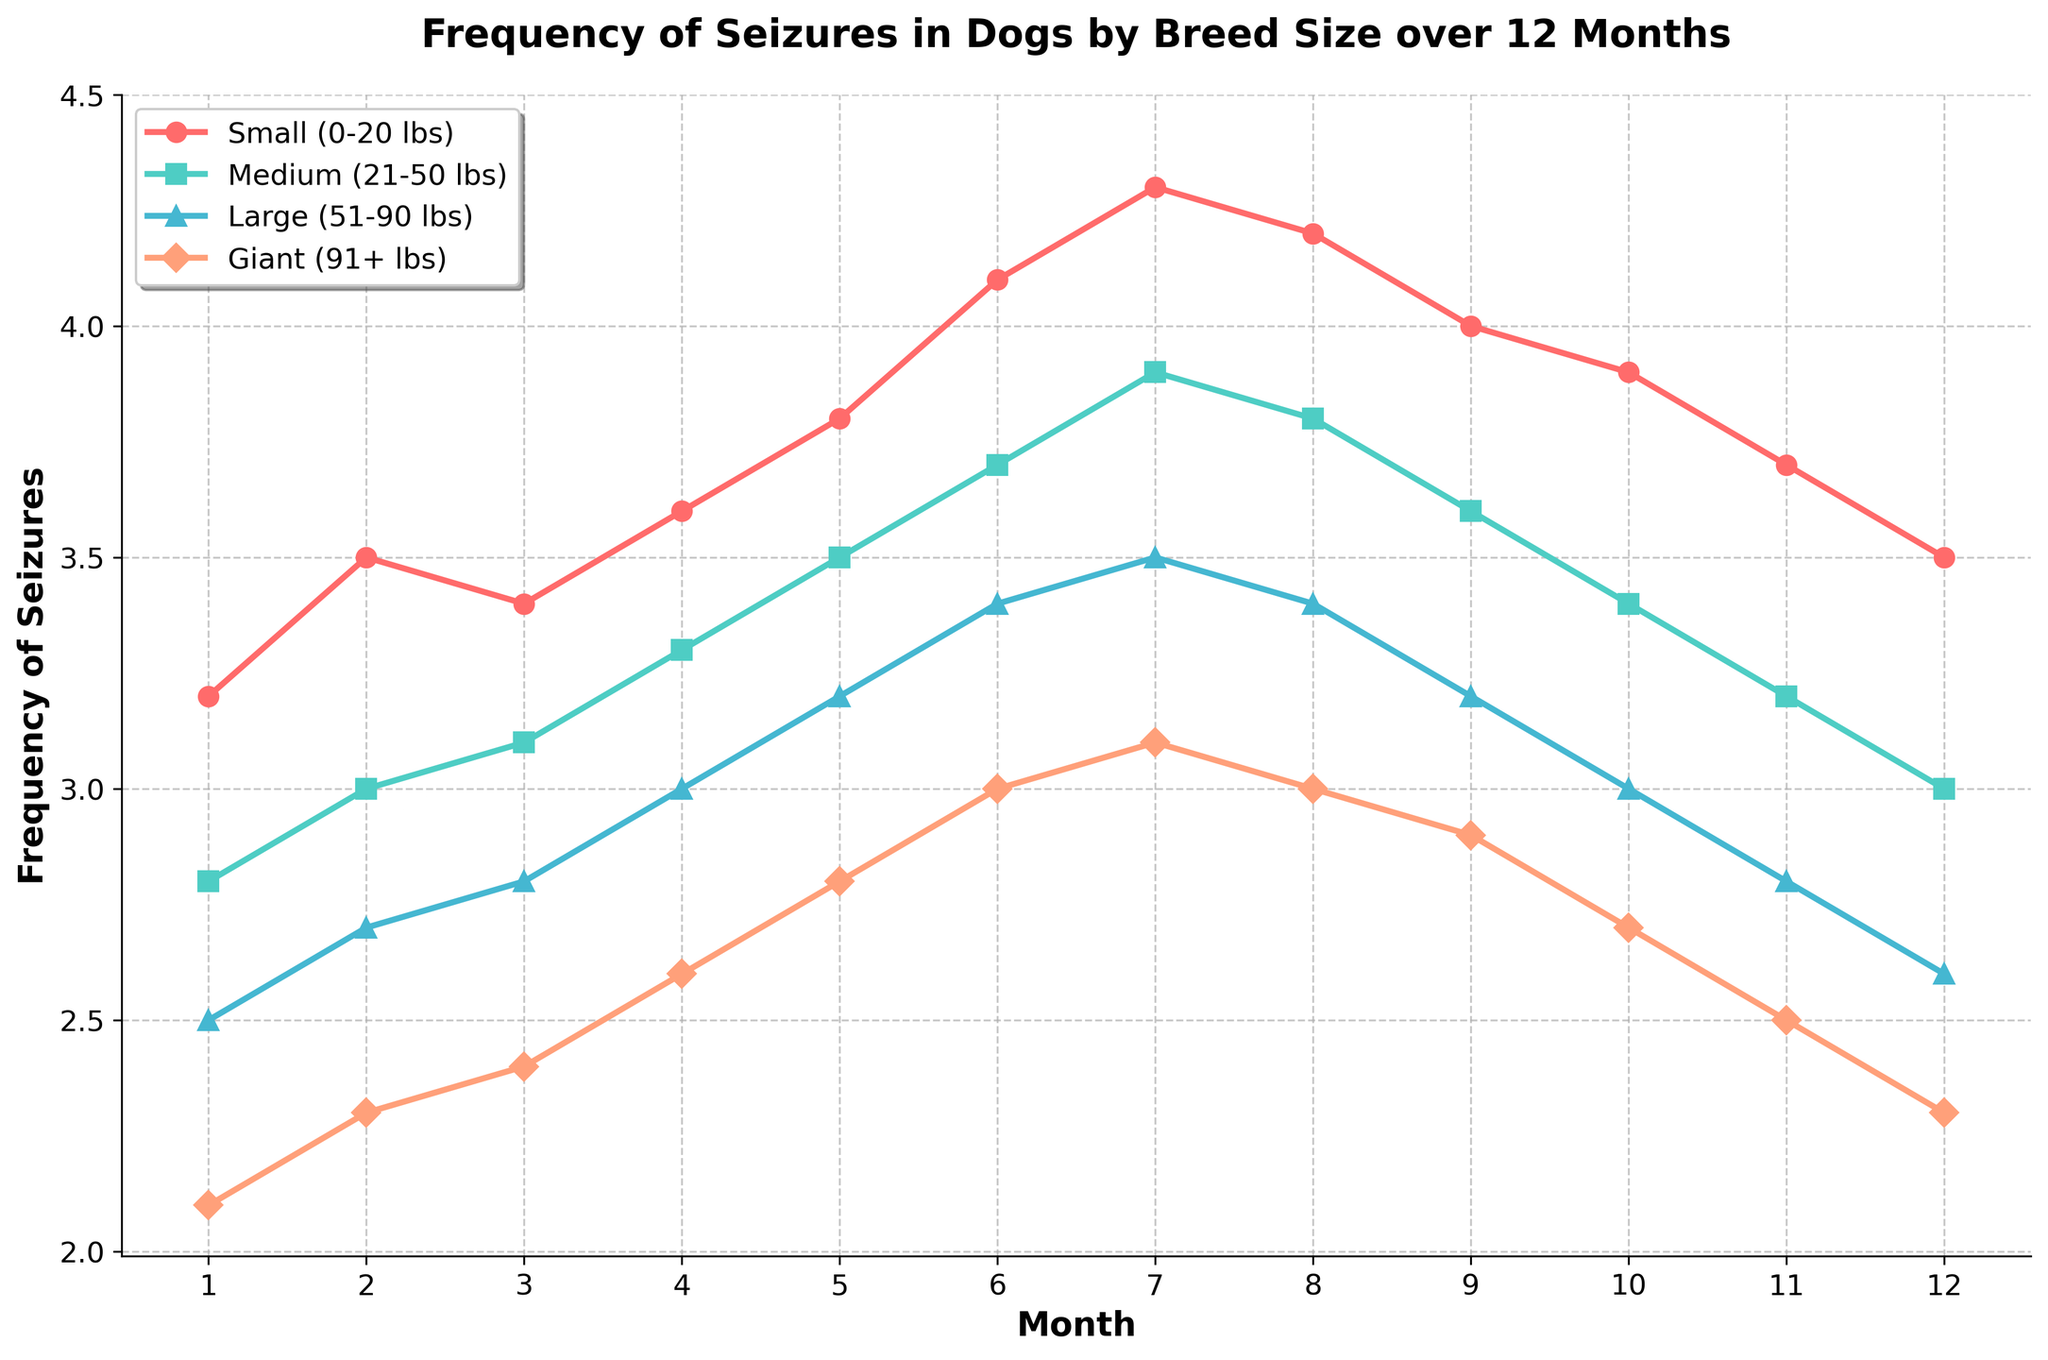What is the general trend for the frequency of seizures in small breed dogs over 12 months? The figure shows the frequency of seizures in small breed dogs from month 1 to month 12. The trend starts at 3.2 and gradually increases to 4.3 in month 7, then it slightly declines to 3.5 by month 12. The overall trend is an increase followed by a slight decrease.
Answer: Increasing then decreasing Which breed size had the highest frequency of seizures in month 6? By examining the lines in the figure for month 6, we observe that small breed dogs have the highest frequency at 4.1, compared to 3.7 for medium, 3.4 for large, and 3.0 for giant breeds.
Answer: Small breed Which breed size shows the most significant increase in seizure frequency from month 1 to month 12? To find this, we calculate the differences for each breed from month 1 to month 12. Small breeds increase from 3.2 to 3.5 (0.3 increase), medium breeds from 2.8 to 3.0 (0.2 increase), large breeds from 2.5 to 2.6 (0.1 increase), and giant breeds from 2.1 to 2.3 (0.2 increase). The most significant increase is seen in small breed dogs.
Answer: Small breed On average, what is the frequency of seizures for giant breed dogs over the 12-month period? The average is calculated by summing the monthly frequencies and dividing by 12. Summing the values (2.1 + 2.3 + 2.4 + 2.6 + 2.8 + 3.0 + 3.1 + 3.0 + 2.9 + 2.7 + 2.5 + 2.3) equals 33.7. The average frequency is 33.7/12.
Answer: 2.81 How does the trend in seizure frequency for medium breed dogs compare to large breed dogs from month 3 to month 9? Between months 3 and 9, we see a gradual increase in both medium and large breeds. The medium breed rises from 3.1 to 3.6, while the large breed goes from 2.8 to 3.2. Both show a similar upward trend, but medium breeds have a consistently higher frequency throughout this period.
Answer: Both increase, medium breeds higher Which breed size experienced the least fluctuation in seizure frequency over the year? Fluctuation can be observed by the range (difference between the highest and lowest values) for each breed size. Small: 4.3 - 3.2 = 1.1, Medium: 3.9 - 2.8 = 1.1, Large: 3.5 - 2.5 = 1.0, Giant: 3.1 - 2.1 = 1.0. Giant and Large breeds have the same smallest range.
Answer: Giant and Large breeds By month 10, which breed shows a decrease in seizure frequency compared to month 8? Looking at month 8 and month 10, small breeds go from 4.2 to 3.9, medium breeds from 3.8 to 3.4, large breeds from 3.4 to 3.0, and giant breeds from 3.0 to 2.7. All breed sizes show a decrease.
Answer: All breeds What is the increase in seizure frequency for large breed dogs from month 1 to month 6? For large breed dogs, we look at month 1 (2.5) and month 6 (3.4). The increase is 3.4 - 2.5.
Answer: 0.9 Between which months do small breed dogs exhibit their highest increase in seizure frequency? Observing the monthly data for small breed dogs, the step with the highest increase is from month 5 (3.8) to month 6 (4.1). This difference is 0.3, which is the highest increase between consecutive months.
Answer: Month 5 to 6 What is the average monthly seizure frequency for small and medium breeds in the first half (months 1-6)? To find the average, we calculate for each breed for months 1-6. Small breed: (3.2 + 3.5 + 3.4 + 3.6 + 3.8 + 4.1)/6 = 21.6/6 = 3.6. Medium breed: (2.8 + 3.0 + 3.1 + 3.3 + 3.5 + 3.7)/6 = 19.4/6 = 3.23.
Answer: Small: 3.6, Medium: 3.23 